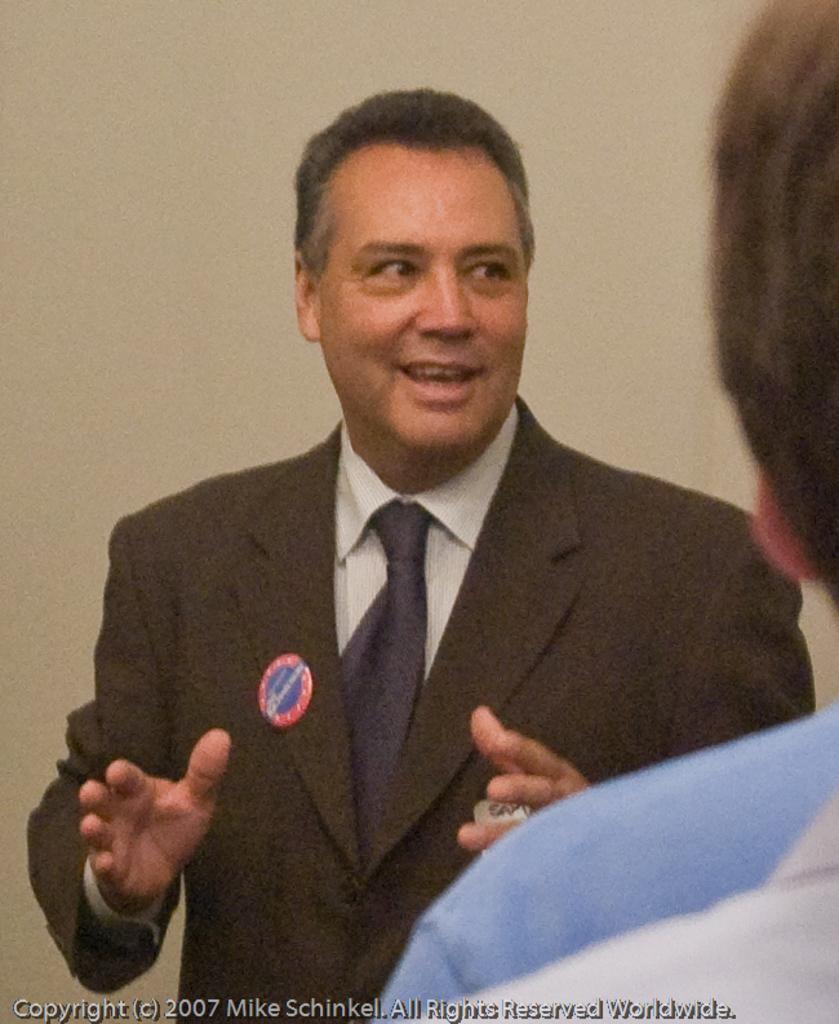In one or two sentences, can you explain what this image depicts? In this picture we can see a man standing here, he wore a suit, in the background there is a wall, we can see another person´s head here, at the left bottom we can see some text. 